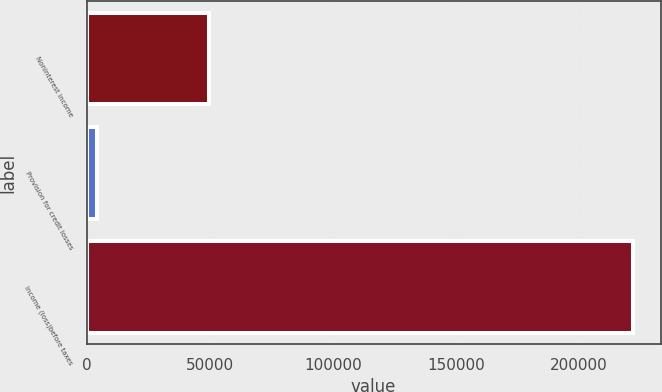Convert chart. <chart><loc_0><loc_0><loc_500><loc_500><bar_chart><fcel>Noninterest income<fcel>Provision for credit losses<fcel>Income (loss)before taxes<nl><fcel>49496<fcel>4150<fcel>222012<nl></chart> 